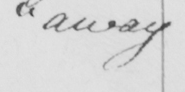What does this handwritten line say? " away 